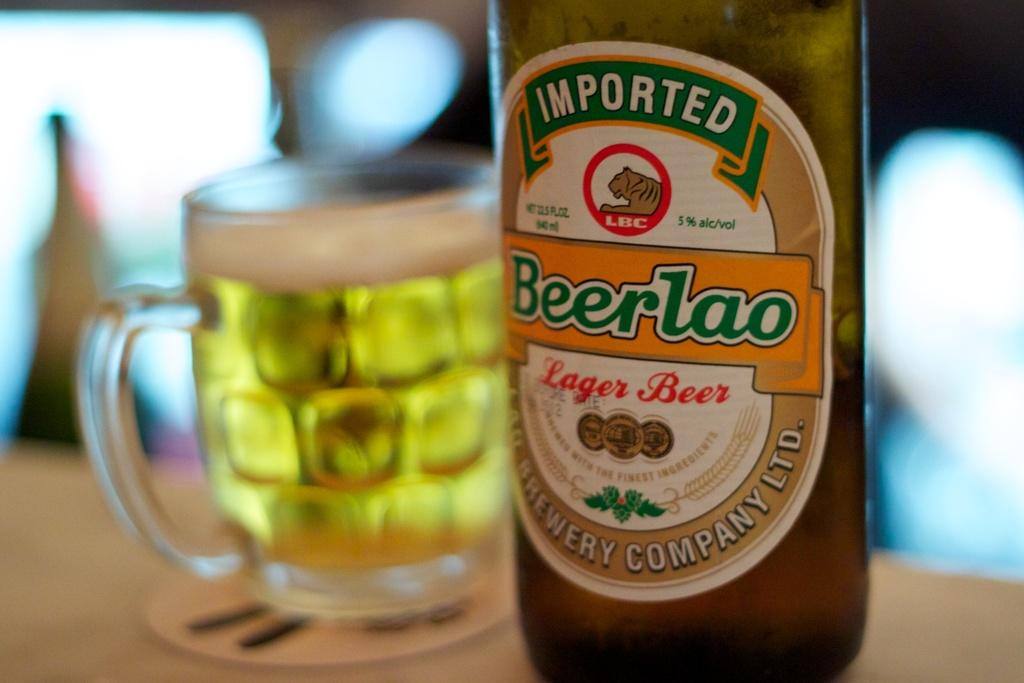<image>
Offer a succinct explanation of the picture presented. A bottle of beer has the word imported at the top. 